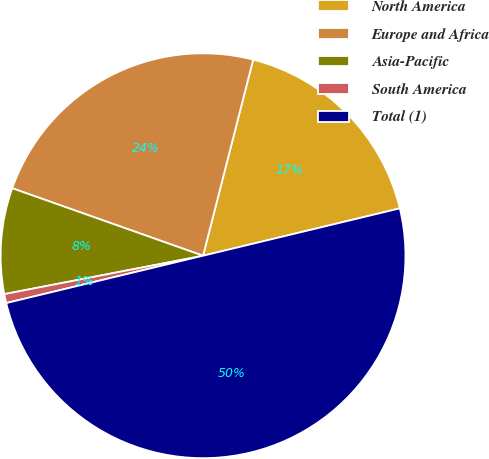<chart> <loc_0><loc_0><loc_500><loc_500><pie_chart><fcel>North America<fcel>Europe and Africa<fcel>Asia-Pacific<fcel>South America<fcel>Total (1)<nl><fcel>17.26%<fcel>23.57%<fcel>8.45%<fcel>0.72%<fcel>50.0%<nl></chart> 